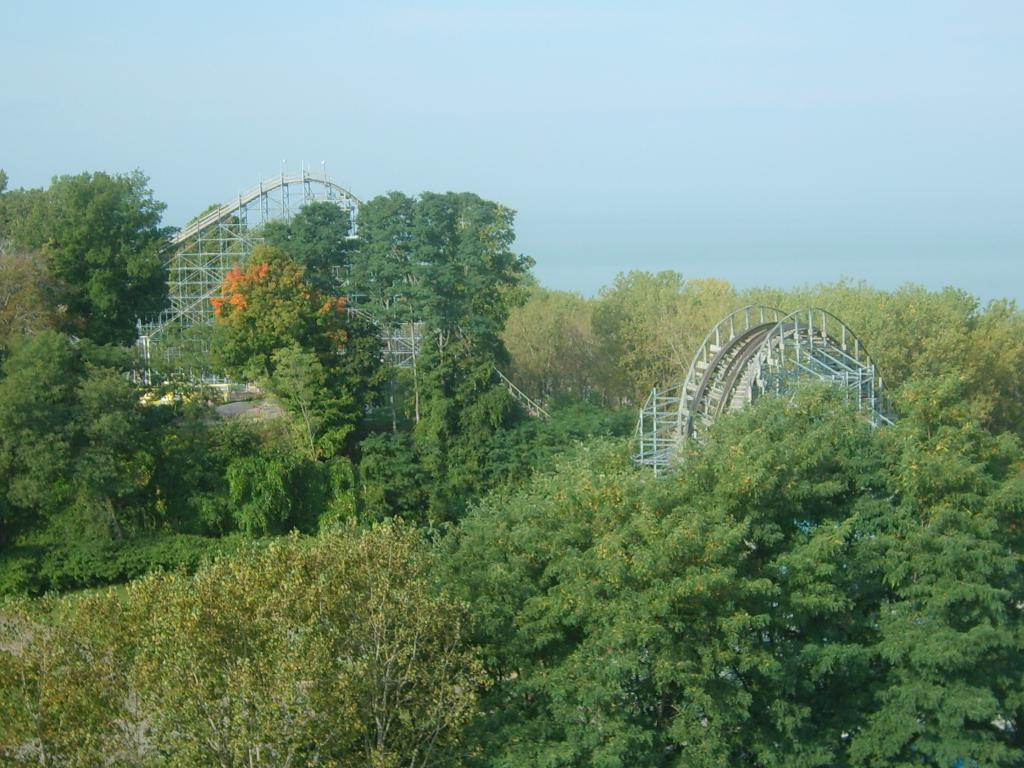What type of natural elements can be seen in the image? There are trees in the image. What else can be seen in the image besides the trees? There are objects in the image. What can be seen in the background of the image? The sky is visible in the background of the image. What type of bedding is visible in the image? There is no bedding present in the image. How many steps can be seen leading up to the trees in the image? There are no steps visible in the image; it only features trees and other objects. 